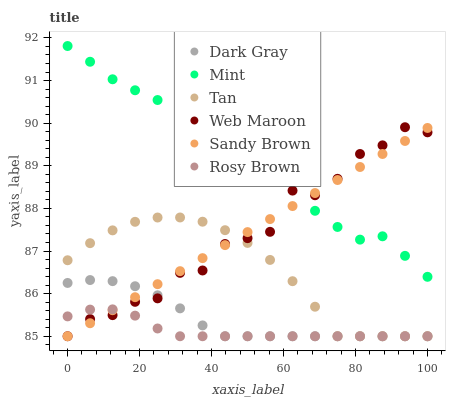Does Rosy Brown have the minimum area under the curve?
Answer yes or no. Yes. Does Mint have the maximum area under the curve?
Answer yes or no. Yes. Does Web Maroon have the minimum area under the curve?
Answer yes or no. No. Does Web Maroon have the maximum area under the curve?
Answer yes or no. No. Is Sandy Brown the smoothest?
Answer yes or no. Yes. Is Web Maroon the roughest?
Answer yes or no. Yes. Is Rosy Brown the smoothest?
Answer yes or no. No. Is Rosy Brown the roughest?
Answer yes or no. No. Does Sandy Brown have the lowest value?
Answer yes or no. Yes. Does Mint have the lowest value?
Answer yes or no. No. Does Mint have the highest value?
Answer yes or no. Yes. Does Web Maroon have the highest value?
Answer yes or no. No. Is Tan less than Mint?
Answer yes or no. Yes. Is Mint greater than Rosy Brown?
Answer yes or no. Yes. Does Rosy Brown intersect Web Maroon?
Answer yes or no. Yes. Is Rosy Brown less than Web Maroon?
Answer yes or no. No. Is Rosy Brown greater than Web Maroon?
Answer yes or no. No. Does Tan intersect Mint?
Answer yes or no. No. 